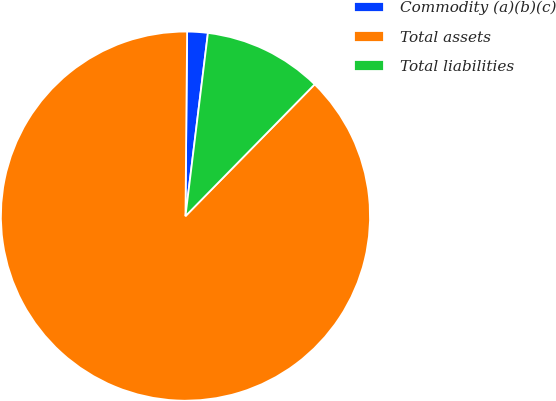<chart> <loc_0><loc_0><loc_500><loc_500><pie_chart><fcel>Commodity (a)(b)(c)<fcel>Total assets<fcel>Total liabilities<nl><fcel>1.8%<fcel>87.8%<fcel>10.4%<nl></chart> 